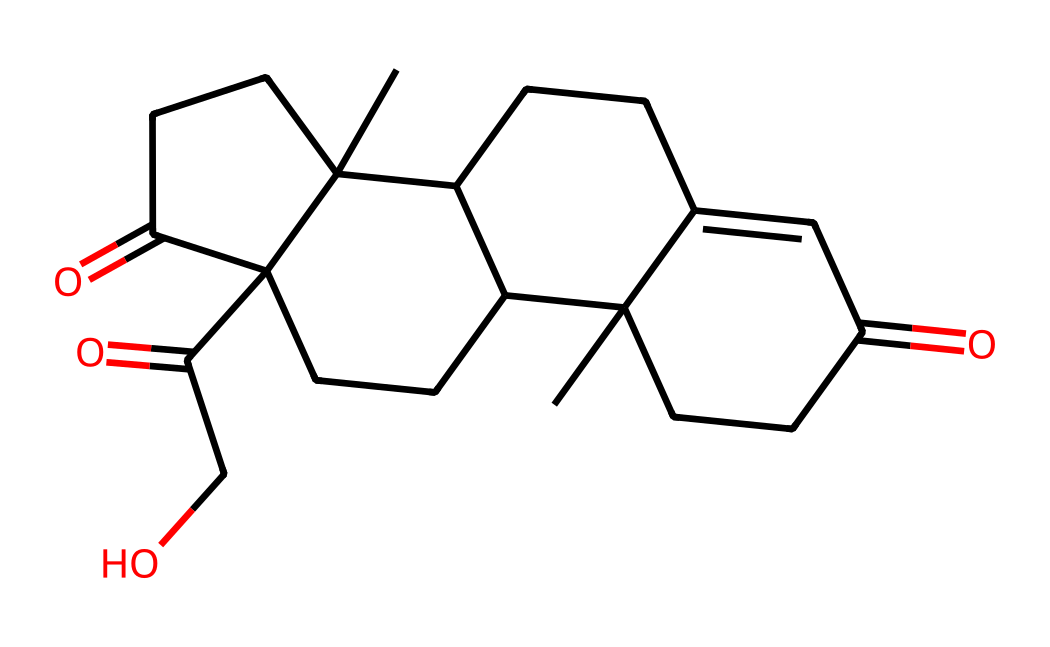how many carbon atoms are present in cortisol? By examining the SMILES representation, count the instances of the letter "C" which indicates carbon atoms. The structure shows 21 carbon atoms.
Answer: 21 what is the functional group characteristic of cortisol? In the SMILES representation, the "C(=O)" indicates the presence of a carbonyl group, which is indicative of ketones and aldehydes. Additionally, "C(=O)CO" suggests a hydroxyl group presence as well.
Answer: carbonyl and hydroxyl how many rings are in the cortisol structure? The SMILES representation can be visualized to reveal ring structures formed by 'C' and their connectivity, leading to the identification of four distinct rings in cortisol.
Answer: 4 does cortisol contain a hydroxyl group? The presence of "CO" in the SMILES indicates a hydroxyl group, confirming that cortisol has one.
Answer: yes is cortisol a steroid hormone? Looking at its structure, cortisol fits the characteristics of steroid hormones, having a four-ring core structure typical of steroids.
Answer: yes what role does cortisol play in the human body? Understanding its function reveals that cortisol is primarily involved in stress response and metabolism regulation in the body.
Answer: stress response how does the structure of cortisol influence its function? Cortisol's structure, with its functional groups and rings, helps it interact with specific receptors in cells, influencing various biological activities, including stress response and metabolism.
Answer: receptor interaction 